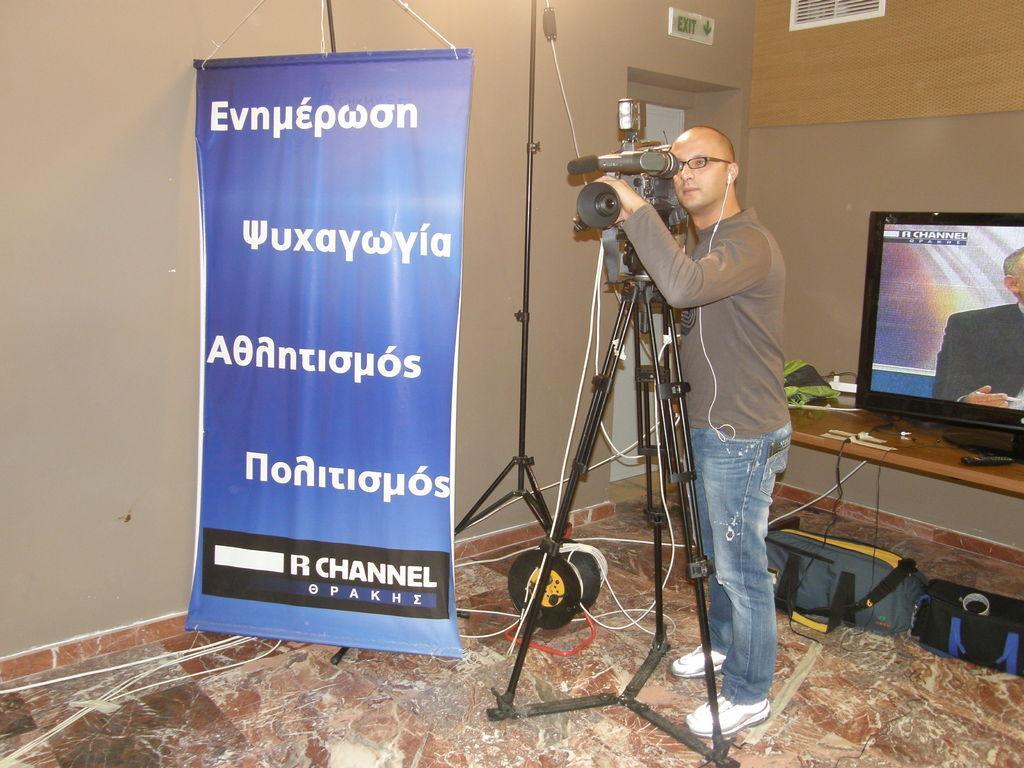Please provide a concise description of this image. In this picture we can see a man wearing spectacles and holding a camera. We can see a camera is fixed on a stand. On the left side of the picture we can see a banner. We can see a sign board on the wall. We can see bags, wires and an object on the floor. In the background we can see a television, remote and objects on the platform. 